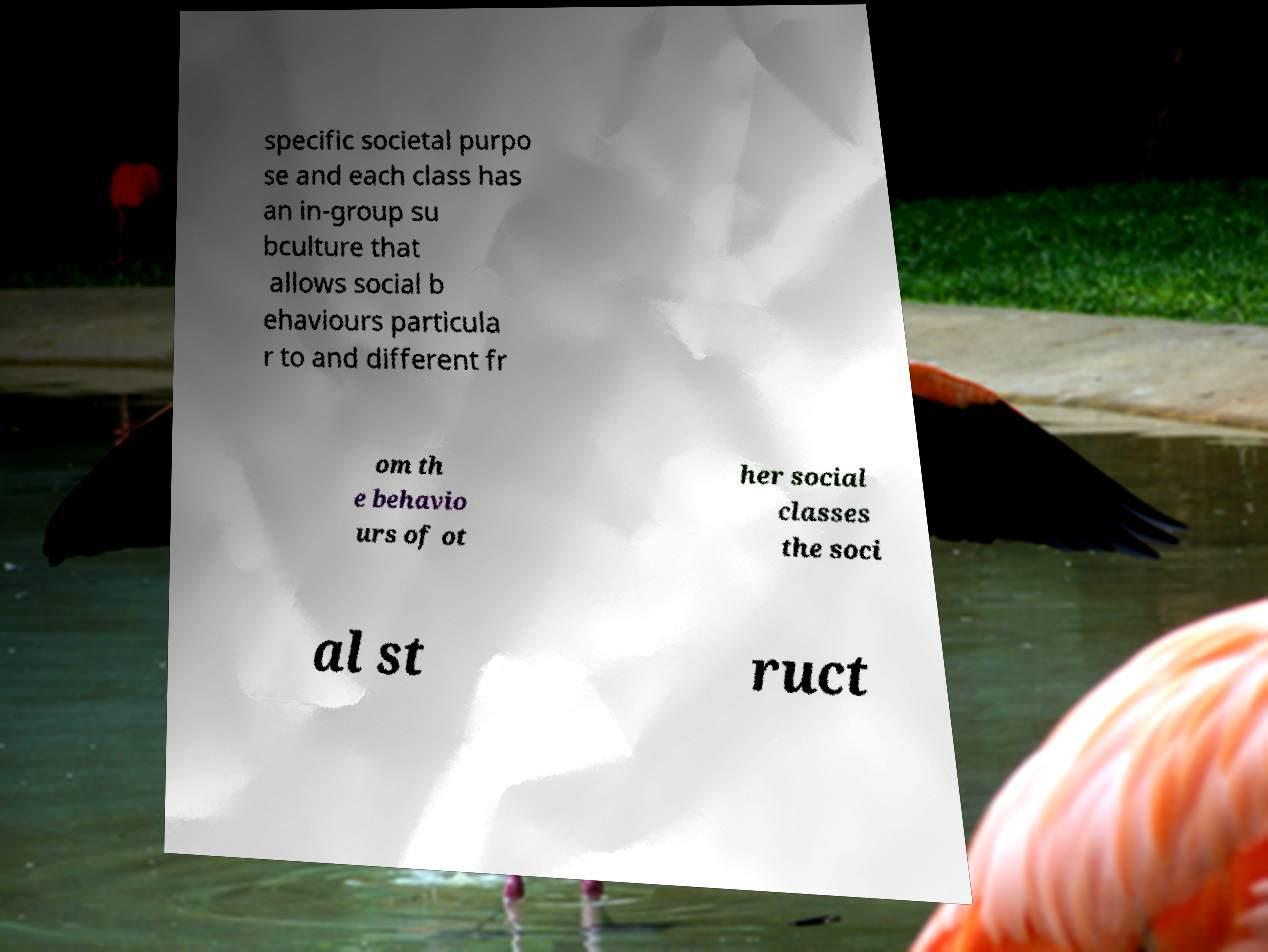Could you extract and type out the text from this image? specific societal purpo se and each class has an in-group su bculture that allows social b ehaviours particula r to and different fr om th e behavio urs of ot her social classes the soci al st ruct 